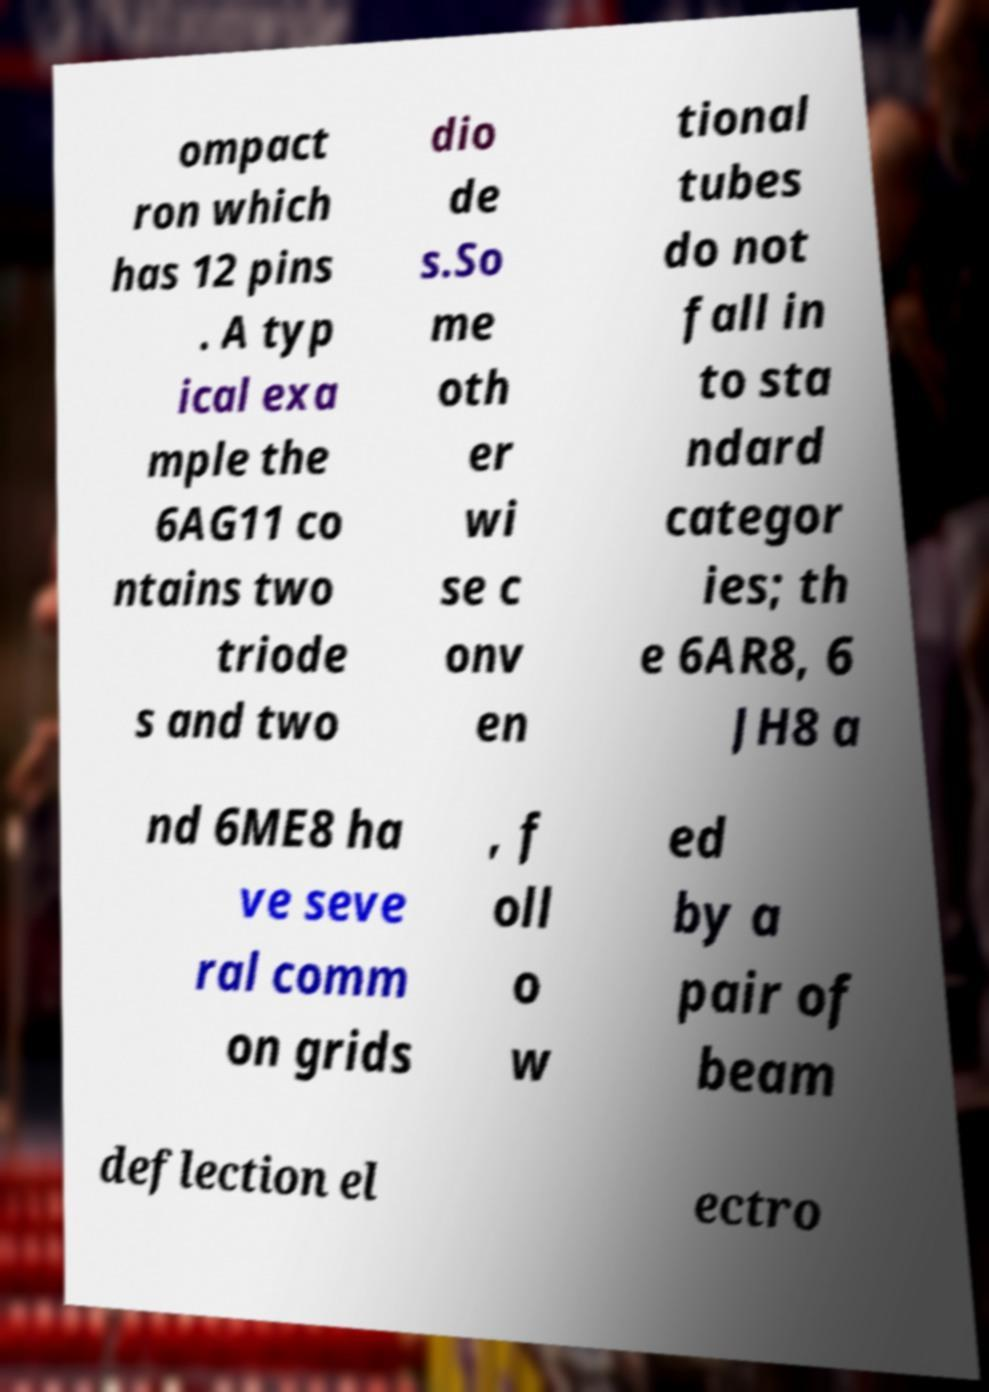Please identify and transcribe the text found in this image. ompact ron which has 12 pins . A typ ical exa mple the 6AG11 co ntains two triode s and two dio de s.So me oth er wi se c onv en tional tubes do not fall in to sta ndard categor ies; th e 6AR8, 6 JH8 a nd 6ME8 ha ve seve ral comm on grids , f oll o w ed by a pair of beam deflection el ectro 